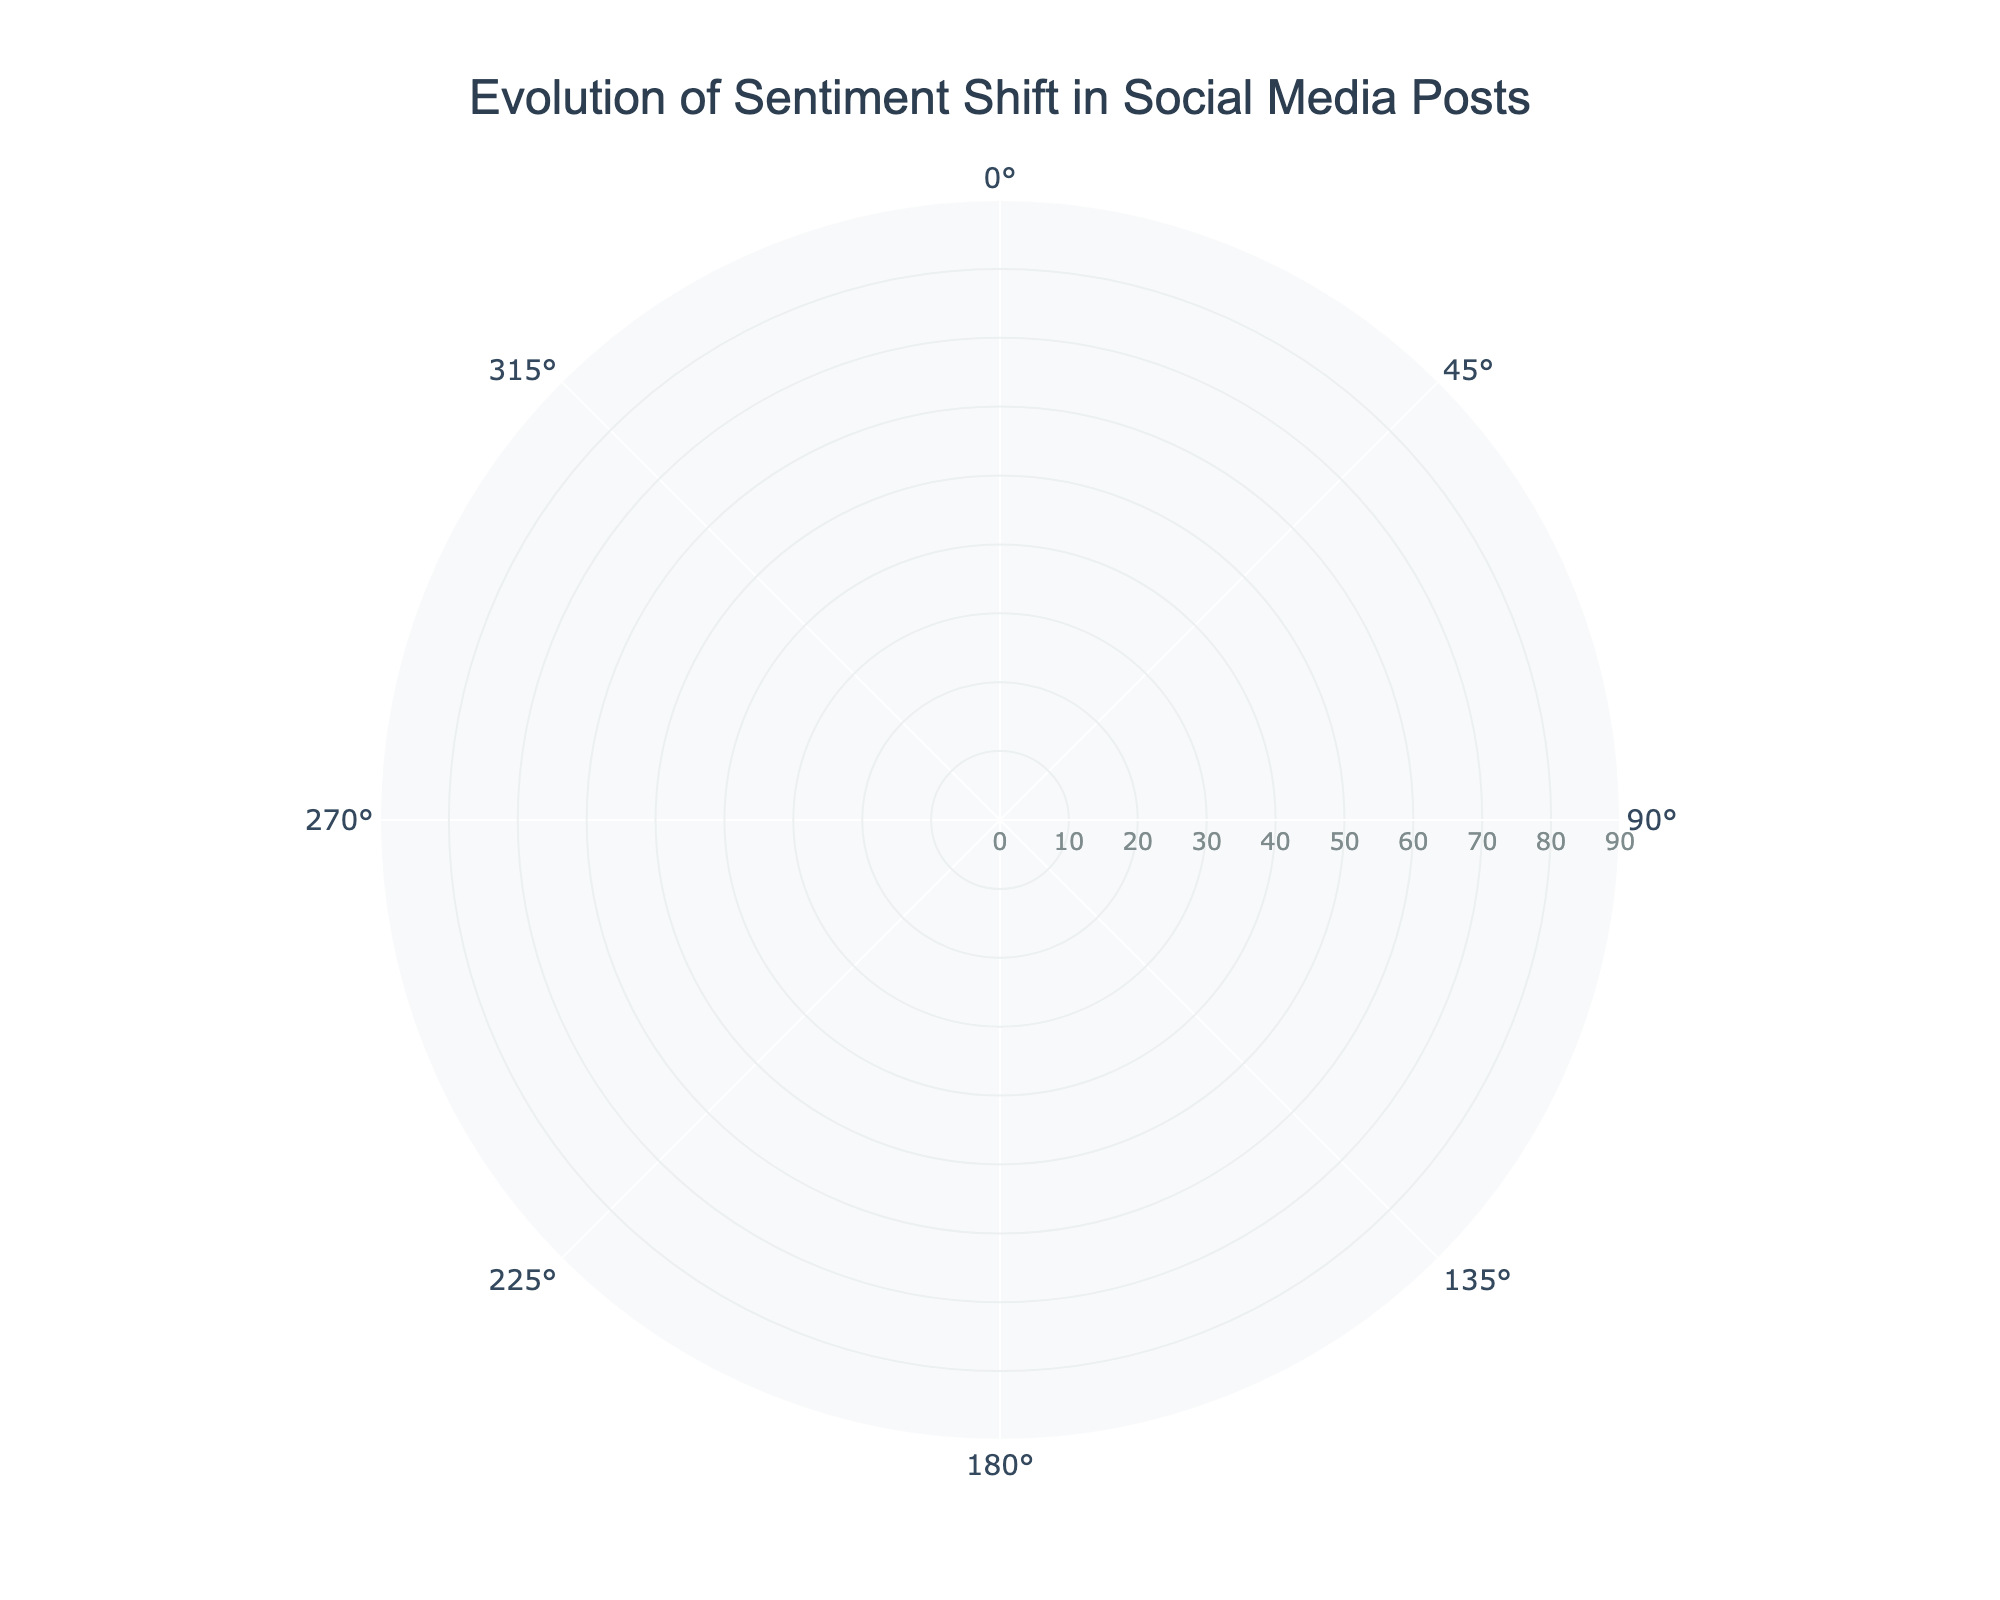What is the title of the figure? The title is located at the top of the figure and specifies what the polar area chart is about.
Answer: Evolution of Sentiment Shift in Social Media Posts How many different types of sentiments are represented in the chart? By observing the legend and the colors used in the chart, we can see the three sentiment categories: Positive, Neutral, and Negative.
Answer: Three Which day shows the highest positive sentiment? By examining the positive values around the chart, the highest positive sentiment is represented by the largest category value in the respective section. For this chart, it's on the last date where the positive sentiment reaches the highest value.
Answer: 2023-10-07 On which date does the neutral sentiment start decreasing significantly? By tracing the neutral sentiment values, we notice a significant drop starts on 2023-10-04.
Answer: 2023-10-04 Compare the positive sentiment values on 2023-10-01 and 2023-10-07. What is the difference? The chart shows that the positive sentiment on 2023-10-01 is 40 and on 2023-10-07 it is 80. The difference is calculated as 80 - 40.
Answer: 40 What is the highest value for the negative sentiment? Reviewing the negative sentiment values shows all negative sentiment readings. The highest value is noticed at two points in time, but remains the same during the week.
Answer: 25 Which date shows the lowest neutral sentiment? By finding and comparing the neutral sentiment values, the lowest can be identified.
Answer: 2023-10-07 How does the positive sentiment change from 2023-10-03 to 2023-10-05? The positive sentiment increases from 55 on 2023-10-03 to 70 on 2023-10-05.
Answer: Increased What is the sum of neutral sentiment values for the first three days? By adding the neutral sentiment values for the dates 2023-10-01, 2023-10-02, and 2023-10-03, we get the total sum: 35 + 30 + 25 = 90.
Answer: 90 Do positive and negative sentiments ever reach the same value at any point during this period? Reviewing the values for positive and negative sentiments across dates, on 2023-10-01, positive and negative sentiments are 40 and 25 respectively, and so forth. They remain distinct throughout.
Answer: No 